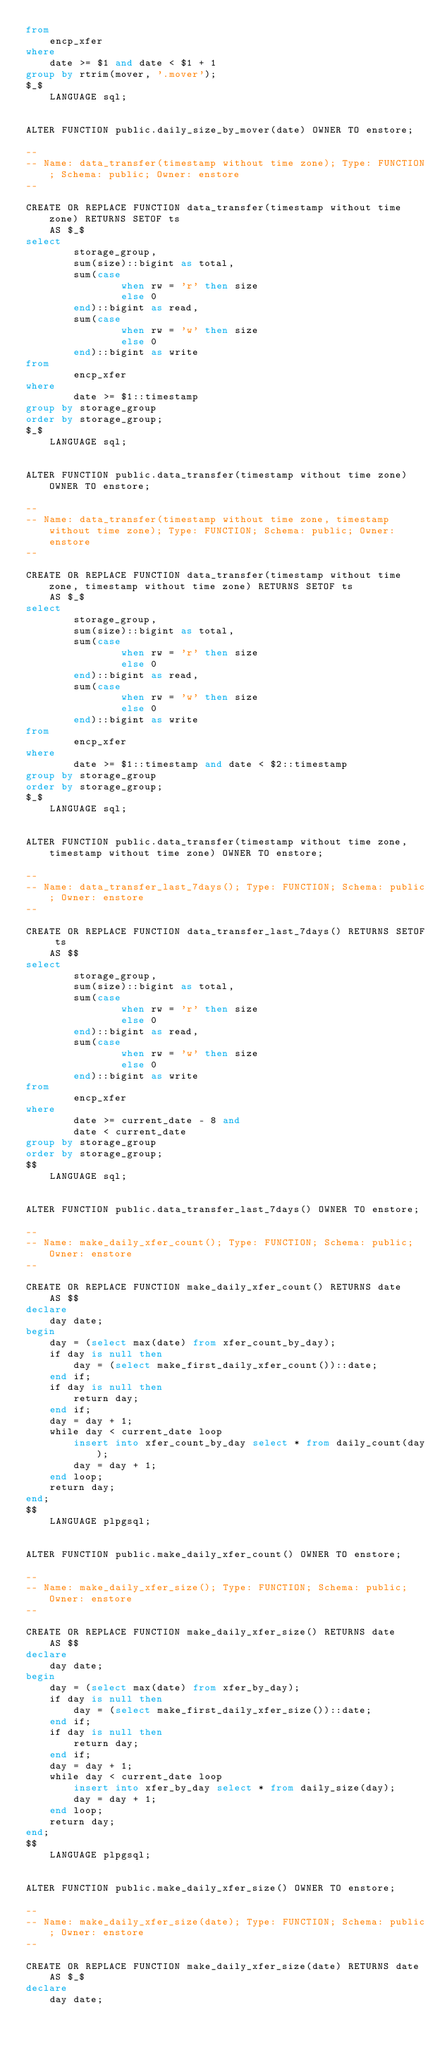<code> <loc_0><loc_0><loc_500><loc_500><_SQL_>from
    encp_xfer
where
    date >= $1 and date < $1 + 1
group by rtrim(mover, '.mover');
$_$
    LANGUAGE sql;


ALTER FUNCTION public.daily_size_by_mover(date) OWNER TO enstore;

--
-- Name: data_transfer(timestamp without time zone); Type: FUNCTION; Schema: public; Owner: enstore
--

CREATE OR REPLACE FUNCTION data_transfer(timestamp without time zone) RETURNS SETOF ts
    AS $_$
select
        storage_group,
        sum(size)::bigint as total,
        sum(case
                when rw = 'r' then size
                else 0
        end)::bigint as read,
        sum(case
                when rw = 'w' then size
                else 0
        end)::bigint as write
from
        encp_xfer
where
        date >= $1::timestamp
group by storage_group
order by storage_group;
$_$
    LANGUAGE sql;


ALTER FUNCTION public.data_transfer(timestamp without time zone) OWNER TO enstore;

--
-- Name: data_transfer(timestamp without time zone, timestamp without time zone); Type: FUNCTION; Schema: public; Owner: enstore
--

CREATE OR REPLACE FUNCTION data_transfer(timestamp without time zone, timestamp without time zone) RETURNS SETOF ts
    AS $_$
select
        storage_group,
        sum(size)::bigint as total,
        sum(case
                when rw = 'r' then size
                else 0
        end)::bigint as read,
        sum(case
                when rw = 'w' then size
                else 0
        end)::bigint as write
from
        encp_xfer
where
        date >= $1::timestamp and date < $2::timestamp
group by storage_group
order by storage_group;
$_$
    LANGUAGE sql;


ALTER FUNCTION public.data_transfer(timestamp without time zone, timestamp without time zone) OWNER TO enstore;

--
-- Name: data_transfer_last_7days(); Type: FUNCTION; Schema: public; Owner: enstore
--

CREATE OR REPLACE FUNCTION data_transfer_last_7days() RETURNS SETOF ts
    AS $$
select
        storage_group,
        sum(size)::bigint as total,
        sum(case
                when rw = 'r' then size
                else 0
        end)::bigint as read,
        sum(case
                when rw = 'w' then size
                else 0
        end)::bigint as write
from
        encp_xfer
where
        date >= current_date - 8 and
        date < current_date
group by storage_group
order by storage_group;
$$
    LANGUAGE sql;


ALTER FUNCTION public.data_transfer_last_7days() OWNER TO enstore;

--
-- Name: make_daily_xfer_count(); Type: FUNCTION; Schema: public; Owner: enstore
--

CREATE OR REPLACE FUNCTION make_daily_xfer_count() RETURNS date
    AS $$
declare
	day date;
begin
	day = (select max(date) from xfer_count_by_day);
	if day is null then
		day = (select make_first_daily_xfer_count())::date;
	end if;
	if day is null then
		return day;
	end if;
	day = day + 1;
	while day < current_date loop
		insert into xfer_count_by_day select * from daily_count(day);
		day = day + 1;
	end loop;
	return day;
end;
$$
    LANGUAGE plpgsql;


ALTER FUNCTION public.make_daily_xfer_count() OWNER TO enstore;

--
-- Name: make_daily_xfer_size(); Type: FUNCTION; Schema: public; Owner: enstore
--

CREATE OR REPLACE FUNCTION make_daily_xfer_size() RETURNS date
    AS $$
declare
	day date;
begin
	day = (select max(date) from xfer_by_day);
	if day is null then
		day = (select make_first_daily_xfer_size())::date;
	end if;
	if day is null then
		return day;
	end if;
	day = day + 1;
	while day < current_date loop
		insert into xfer_by_day select * from daily_size(day);
		day = day + 1;
	end loop;
	return day;
end;
$$
    LANGUAGE plpgsql;


ALTER FUNCTION public.make_daily_xfer_size() OWNER TO enstore;

--
-- Name: make_daily_xfer_size(date); Type: FUNCTION; Schema: public; Owner: enstore
--

CREATE OR REPLACE FUNCTION make_daily_xfer_size(date) RETURNS date
    AS $_$
declare
	day date;</code> 